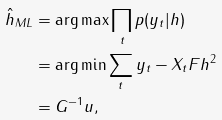<formula> <loc_0><loc_0><loc_500><loc_500>\hat { h } _ { M L } & = \arg \max \prod _ { t } p ( y _ { t } | h ) \\ & = \arg \min \sum _ { t } \| y _ { t } - X _ { t } F h \| ^ { 2 } \\ & = G ^ { - 1 } u ,</formula> 